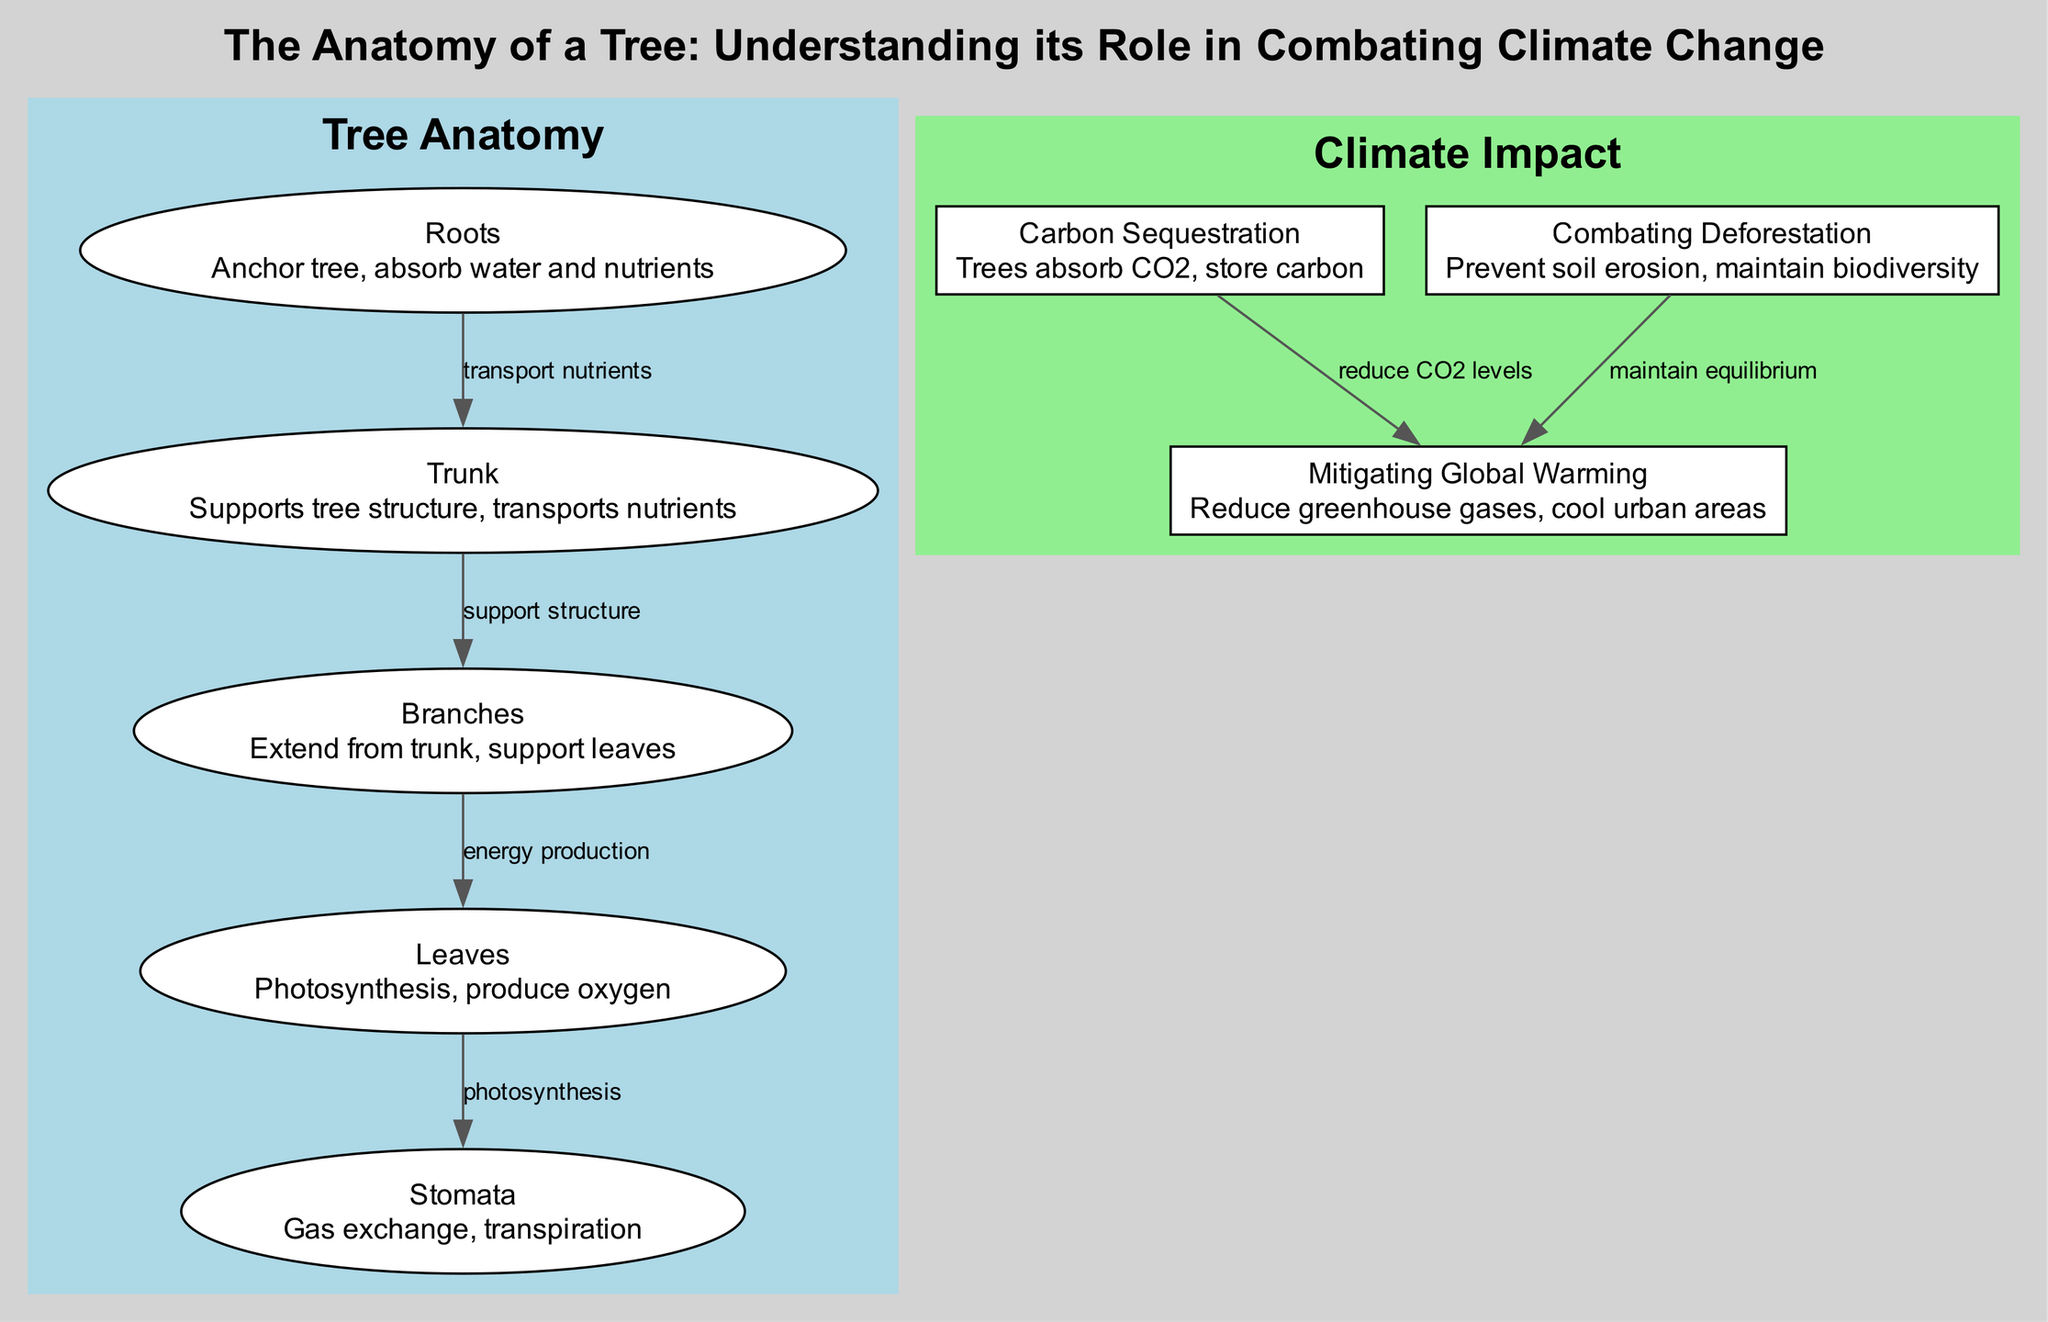What is the role of leaves? The diagram describes that leaves are responsible for photosynthesis, which produces oxygen. This role is essential for the tree's contribution to ecological balance.
Answer: Photosynthesis, produce oxygen What connects the roots and trunk? The diagram shows an edge labeled "transport nutrients" indicating that the roots transport nutrients to the trunk. This connection is crucial for the tree's growth and stability.
Answer: Transport nutrients How many major parts of a tree are highlighted in the diagram? The diagram explicitly lists four major parts: roots, trunk, branches, and leaves under tree anatomy. Thus, the count of these highlighted parts is four.
Answer: Four What impact do trees have on soil erosion? The diagram notes that trees combat deforestation and prevent soil erosion, indicating their role in maintaining soil health and stability, especially in forested areas.
Answer: Prevent soil erosion How does carbon sequestration link to global warming mitigation? The diagram illustrates a connection where carbon sequestration reduces CO2 levels, which directly contributes to mitigating global warming by lowering greenhouse gas concentrations in the atmosphere.
Answer: Reduce CO2 levels What is the role of stomata in leaves? The diagram describes stomata as crucial for gas exchange and transpiration, highlighting their function in regulating water loss and facilitating the intake of carbon dioxide needed for photosynthesis.
Answer: Gas exchange, transpiration How do branches support leaves? The diagram states that branches extend from the trunk and support leaves, indicating that they play a vital structural role which aids in maximizing leaves' exposure to sunlight for photosynthesis.
Answer: Support leaves What is the relationship between combating deforestation and global warming mitigation? The diagram depicts an edge stating "maintain equilibrium" showing that combating deforestation helps to stabilize ecosystems which is essential for global warming mitigation, indicating a symbiotic relationship.
Answer: Maintain equilibrium 